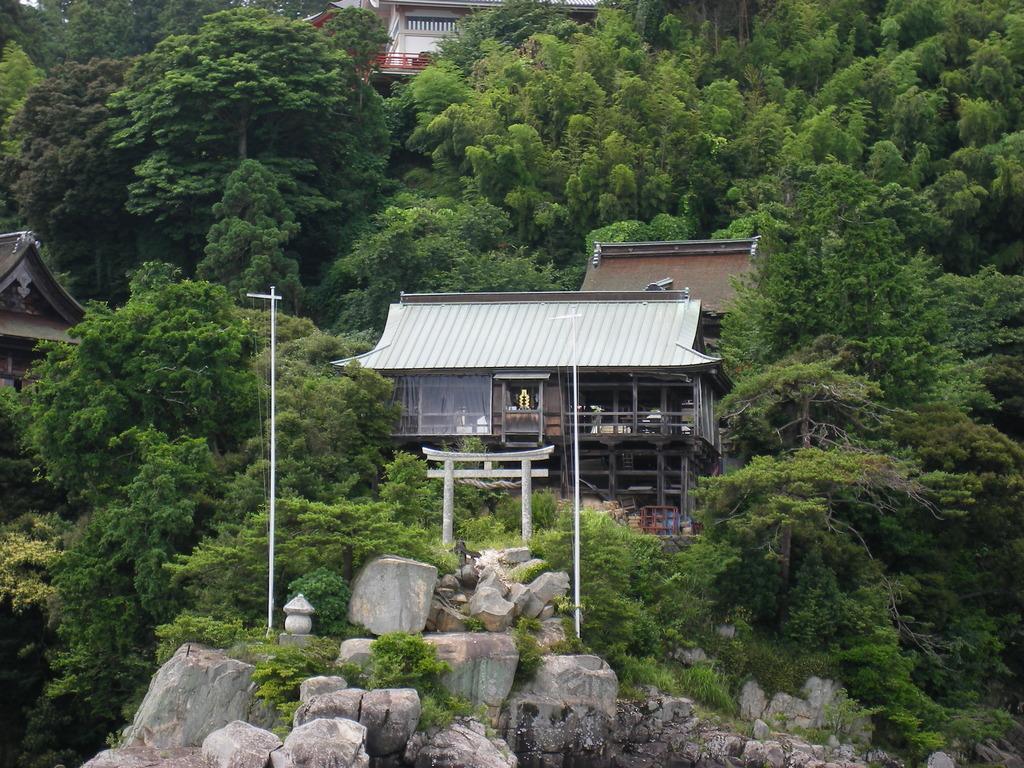Can you describe this image briefly? This is an outside view. At the bottom there are few rocks and two poles. In the background there are few buildings and many trees. 